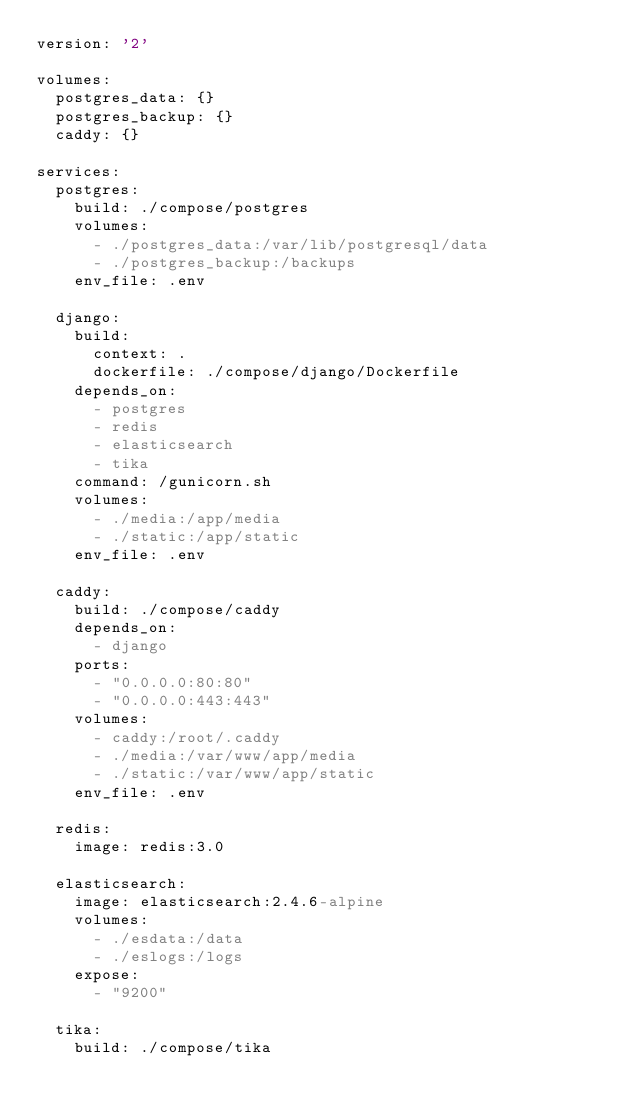Convert code to text. <code><loc_0><loc_0><loc_500><loc_500><_YAML_>version: '2'

volumes:
  postgres_data: {}
  postgres_backup: {}
  caddy: {}

services:
  postgres:
    build: ./compose/postgres
    volumes:
      - ./postgres_data:/var/lib/postgresql/data
      - ./postgres_backup:/backups
    env_file: .env

  django:
    build:
      context: .
      dockerfile: ./compose/django/Dockerfile
    depends_on:
      - postgres
      - redis
      - elasticsearch
      - tika
    command: /gunicorn.sh
    volumes:
      - ./media:/app/media
      - ./static:/app/static
    env_file: .env

  caddy:
    build: ./compose/caddy
    depends_on:
      - django
    ports:
      - "0.0.0.0:80:80"
      - "0.0.0.0:443:443"
    volumes:
      - caddy:/root/.caddy
      - ./media:/var/www/app/media
      - ./static:/var/www/app/static
    env_file: .env

  redis:
    image: redis:3.0

  elasticsearch:
    image: elasticsearch:2.4.6-alpine
    volumes:
      - ./esdata:/data
      - ./eslogs:/logs
    expose:
      - "9200"

  tika:
    build: ./compose/tika
</code> 